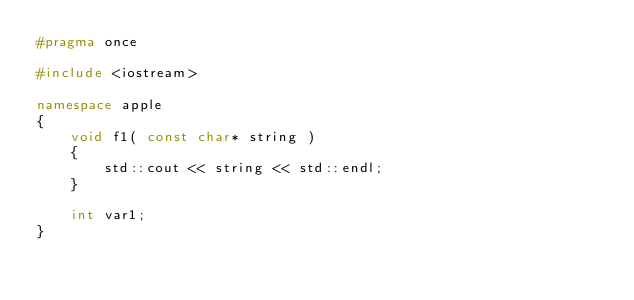<code> <loc_0><loc_0><loc_500><loc_500><_C++_>#pragma once

#include <iostream>

namespace apple
{
	void f1( const char* string )
	{
		std::cout << string << std::endl;
	}

	int var1;
}
</code> 